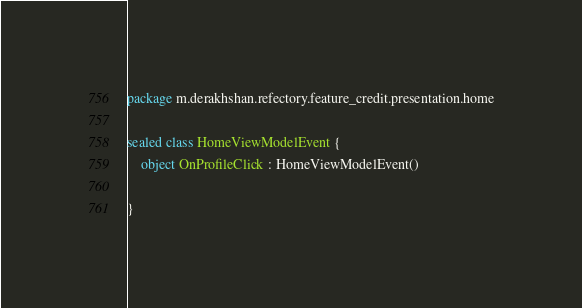Convert code to text. <code><loc_0><loc_0><loc_500><loc_500><_Kotlin_>package m.derakhshan.refectory.feature_credit.presentation.home

sealed class HomeViewModelEvent {
    object OnProfileClick : HomeViewModelEvent()

}
</code> 